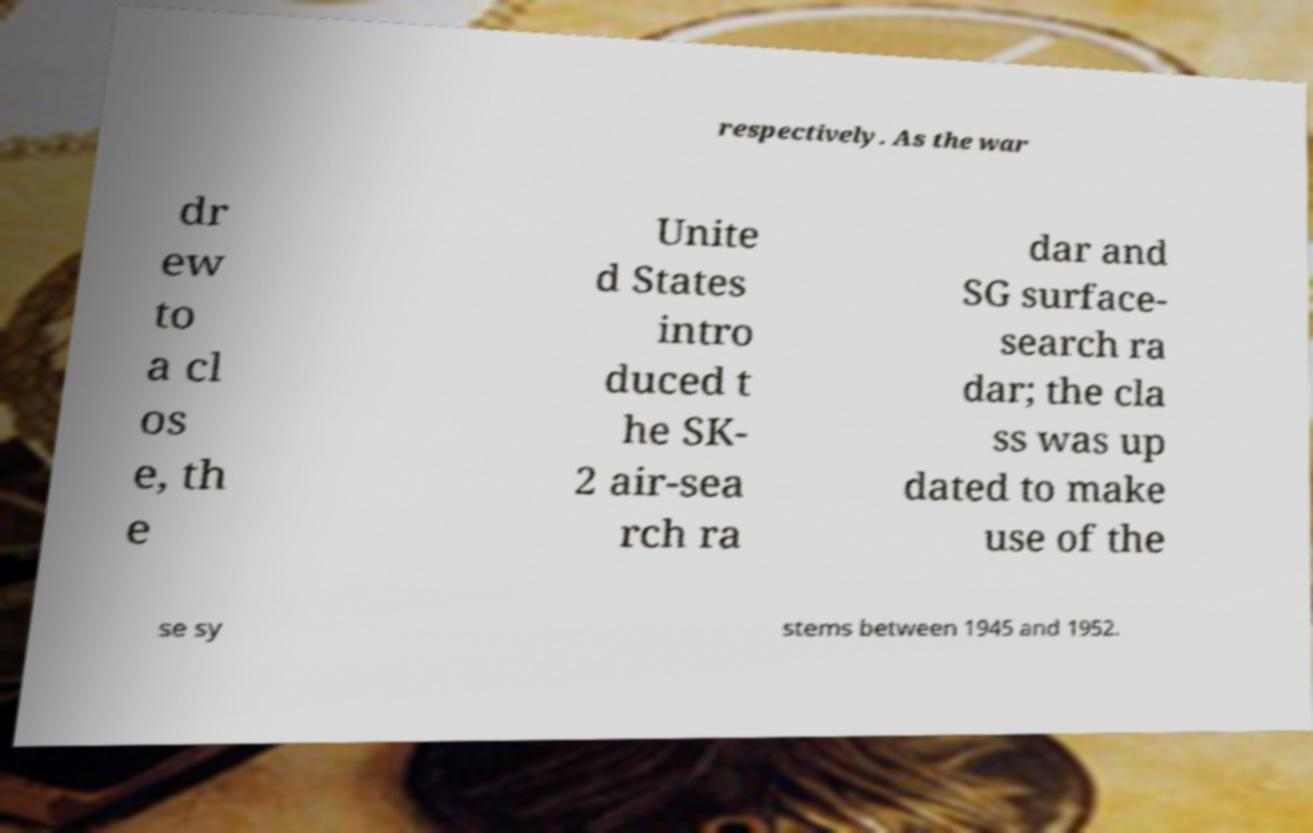I need the written content from this picture converted into text. Can you do that? respectively. As the war dr ew to a cl os e, th e Unite d States intro duced t he SK- 2 air-sea rch ra dar and SG surface- search ra dar; the cla ss was up dated to make use of the se sy stems between 1945 and 1952. 